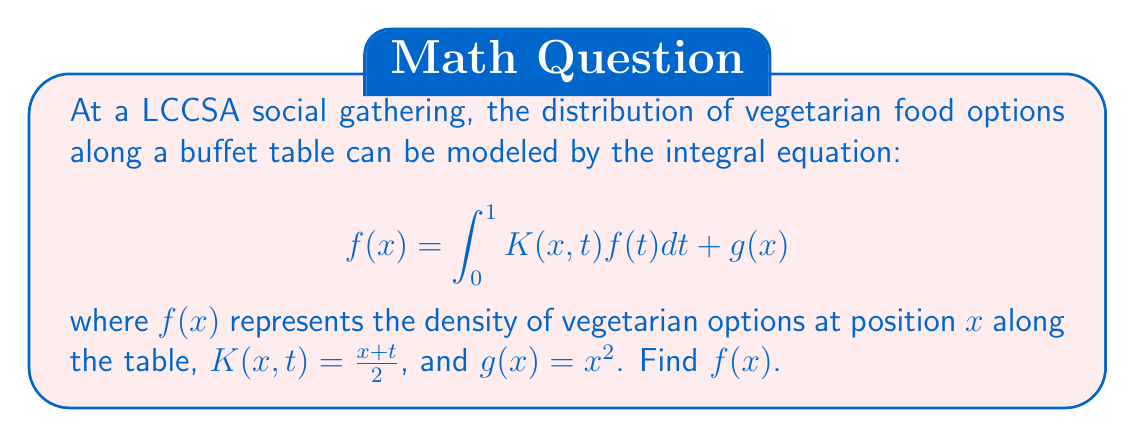Provide a solution to this math problem. To solve this integral equation, we'll use the method of successive approximations:

1) Start with an initial guess: $f_0(x) = g(x) = x^2$

2) Iterate using the formula:
   $$f_{n+1}(x) = \int_0^1 K(x,t)f_n(t)dt + g(x)$$

3) First iteration:
   $$\begin{align*}
   f_1(x) &= \int_0^1 \frac{x+t}{2}t^2dt + x^2 \\
   &= \frac{x}{2}\int_0^1 t^2dt + \frac{1}{2}\int_0^1 t^3dt + x^2 \\
   &= \frac{x}{2}\cdot\frac{1}{3} + \frac{1}{2}\cdot\frac{1}{4} + x^2 \\
   &= \frac{x}{6} + \frac{1}{8} + x^2
   \end{align*}$$

4) Second iteration:
   $$\begin{align*}
   f_2(x) &= \int_0^1 \frac{x+t}{2}(\frac{t}{6} + \frac{1}{8} + t^2)dt + x^2 \\
   &= \frac{x}{2}\int_0^1 (\frac{t}{6} + \frac{1}{8} + t^2)dt + \frac{1}{2}\int_0^1 (t^2/6 + t/8 + t^3)dt + x^2 \\
   &= \frac{x}{2}(\frac{1}{12} + \frac{1}{8} + \frac{1}{3}) + \frac{1}{2}(\frac{1}{18} + \frac{1}{32} + \frac{1}{4}) + x^2 \\
   &= \frac{x}{4} + \frac{13}{72} + x^2
   \end{align*}$$

5) The pattern emerges: $f_n(x) = ax + b + x^2$, where $a$ and $b$ are constants.

6) Substituting this form into the original equation:
   $$\begin{align*}
   ax + b + x^2 &= \int_0^1 \frac{x+t}{2}(at + b + t^2)dt + x^2 \\
   &= \frac{x}{2}\int_0^1 (at + b + t^2)dt + \frac{1}{2}\int_0^1 (at^2 + bt + t^3)dt + x^2 \\
   &= \frac{x}{2}(\frac{a}{2} + b + \frac{1}{3}) + \frac{1}{2}(\frac{a}{3} + \frac{b}{2} + \frac{1}{4}) + x^2
   \end{align*}$$

7) Comparing coefficients:
   $$\begin{cases}
   a = \frac{1}{2}(\frac{a}{2} + b + \frac{1}{3}) \\
   b = \frac{1}{2}(\frac{a}{3} + \frac{b}{2} + \frac{1}{4})
   \end{cases}$$

8) Solving this system:
   $$a = \frac{1}{3}, b = \frac{1}{6}$$

Therefore, the solution is $f(x) = \frac{1}{3}x + \frac{1}{6} + x^2$.
Answer: $f(x) = \frac{1}{3}x + \frac{1}{6} + x^2$ 